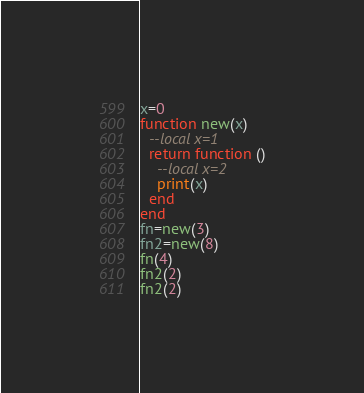<code> <loc_0><loc_0><loc_500><loc_500><_Lua_>x=0
function new(x)
  --local x=1
  return function ()
    --local x=2
    print(x)
  end
end
fn=new(3)
fn2=new(8)
fn(4)
fn2(2)
fn2(2)
</code> 